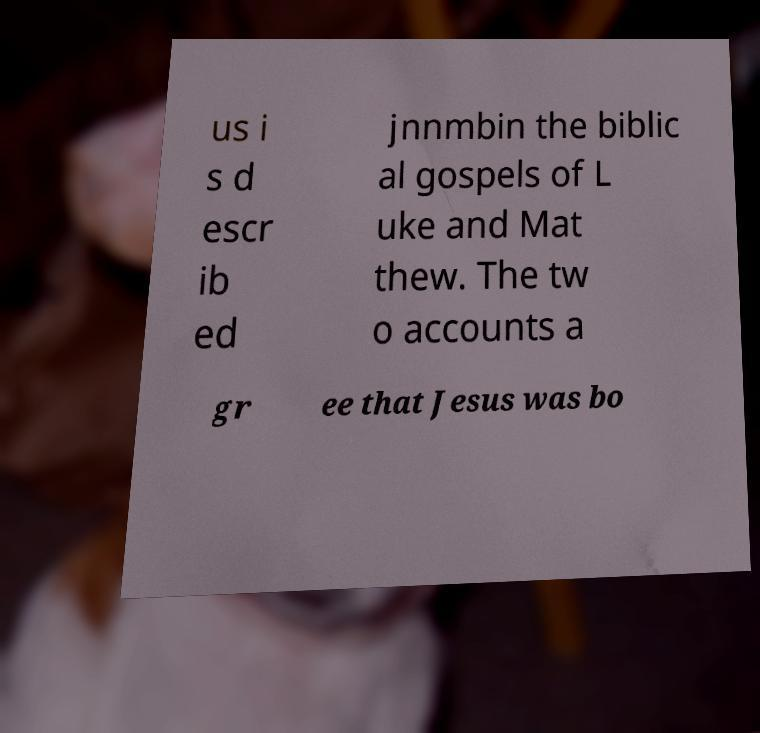Can you accurately transcribe the text from the provided image for me? us i s d escr ib ed jnnmbin the biblic al gospels of L uke and Mat thew. The tw o accounts a gr ee that Jesus was bo 